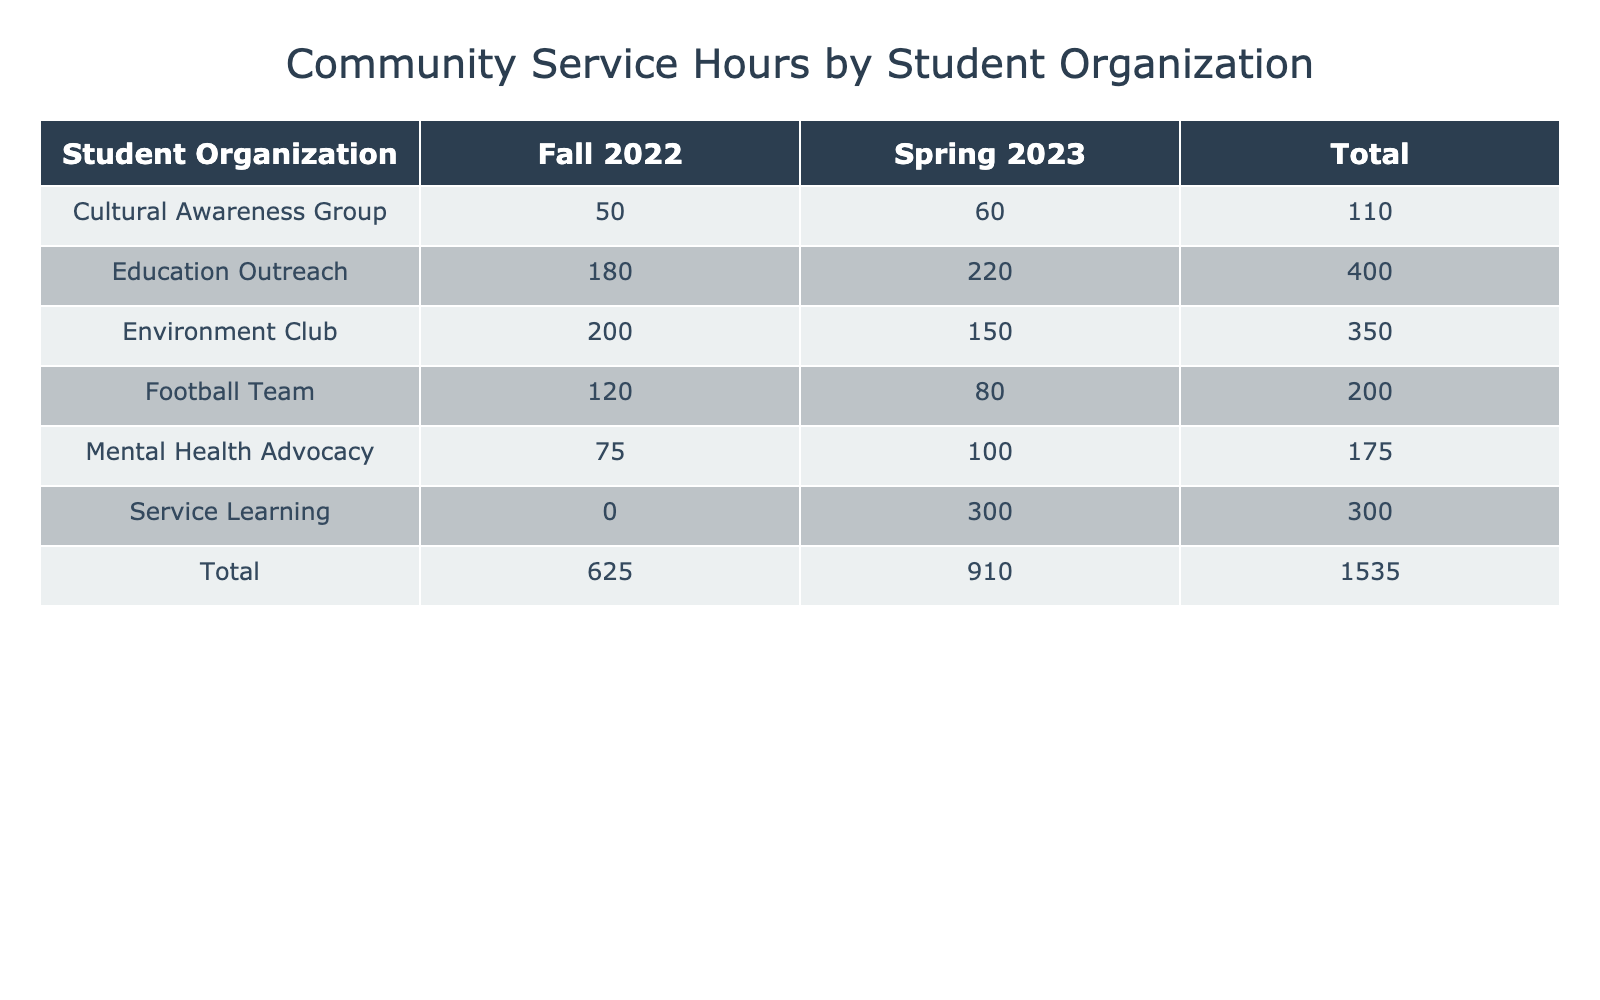What student organization logged the most community service hours in Fall 2022? The table shows community service hours for each organization by semester. In Fall 2022, the Environment Club logged 200 hours, which is the highest of all organizations in that semester.
Answer: Environment Club How many total community service hours did the Football Team log across both semesters? The Football Team logged 120 hours in Fall 2022 and 80 hours in Spring 2023. Adding these two values (120 + 80) results in a total of 200 community service hours.
Answer: 200 Did the Cultural Awareness Group have more service hours in Spring 2023 than in Fall 2022? The Cultural Awareness Group logged 50 hours in Fall 2022 and 60 hours in Spring 2023. Since 60 is greater than 50, the statement is true.
Answer: Yes What is the average number of community service hours logged by the Education Outreach across both semesters? Education Outreach logged 180 hours in Fall 2022 and 220 hours in Spring 2023. The total hours (180 + 220) is 400. Since there are 2 semesters, the average is 400 divided by 2, which equals 200.
Answer: 200 Which student organization had the highest increase in community service hours from Fall 2022 to Spring 2023? Calculating the differences: Environment Club (150 - 200 = -50), Service Learning (300 - 0 = 300), Cultural Awareness Group (60 - 50 = 10), Mental Health Advocacy (100 - 75 = 25), Education Outreach (220 - 180 = 40). The Service Learning organization had the highest increase of 300 hours (from 0 to 300).
Answer: Service Learning How many total community service hours were logged by all organizations in Spring 2023? Summing the hours logged in Spring 2023: Football Team (80) + Environment Club (150) + Service Learning (300) + Cultural Awareness Group (60) + Mental Health Advocacy (100) + Education Outreach (220) equals 910 hours logged in total.
Answer: 910 Did any organization log the same amount of community service hours across both semesters? By checking the entries in the table, it can be seen that the Mental Health Advocacy logged 75 hours in Fall 2022 and 100 hours in Spring 2023, which are not equal, confirming that no organization logged the same amount across both semesters.
Answer: No What is the total community service hours logged by the Environment Club and the Education Outreach combined across both semesters? The Environment Club logged 200 hours in Fall 2022 and 150 hours in Spring 2023, resulting in 350 hours total (200 + 150). The Education Outreach logged 180 hours in Fall 2022 and 220 hours in Spring 2023, resulting in 400 hours total (180 + 220). Adding both totals together (350 + 400) gives us 750.
Answer: 750 